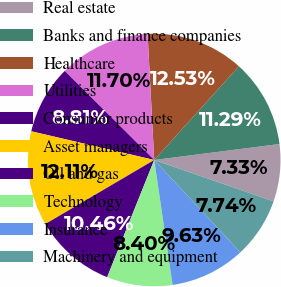<chart> <loc_0><loc_0><loc_500><loc_500><pie_chart><fcel>Real estate<fcel>Banks and finance companies<fcel>Healthcare<fcel>Utilities<fcel>Consumer products<fcel>Asset managers<fcel>Oil and gas<fcel>Technology<fcel>Insurance<fcel>Machinery and equipment<nl><fcel>7.33%<fcel>11.29%<fcel>12.53%<fcel>11.7%<fcel>8.81%<fcel>12.11%<fcel>10.46%<fcel>8.4%<fcel>9.63%<fcel>7.74%<nl></chart> 